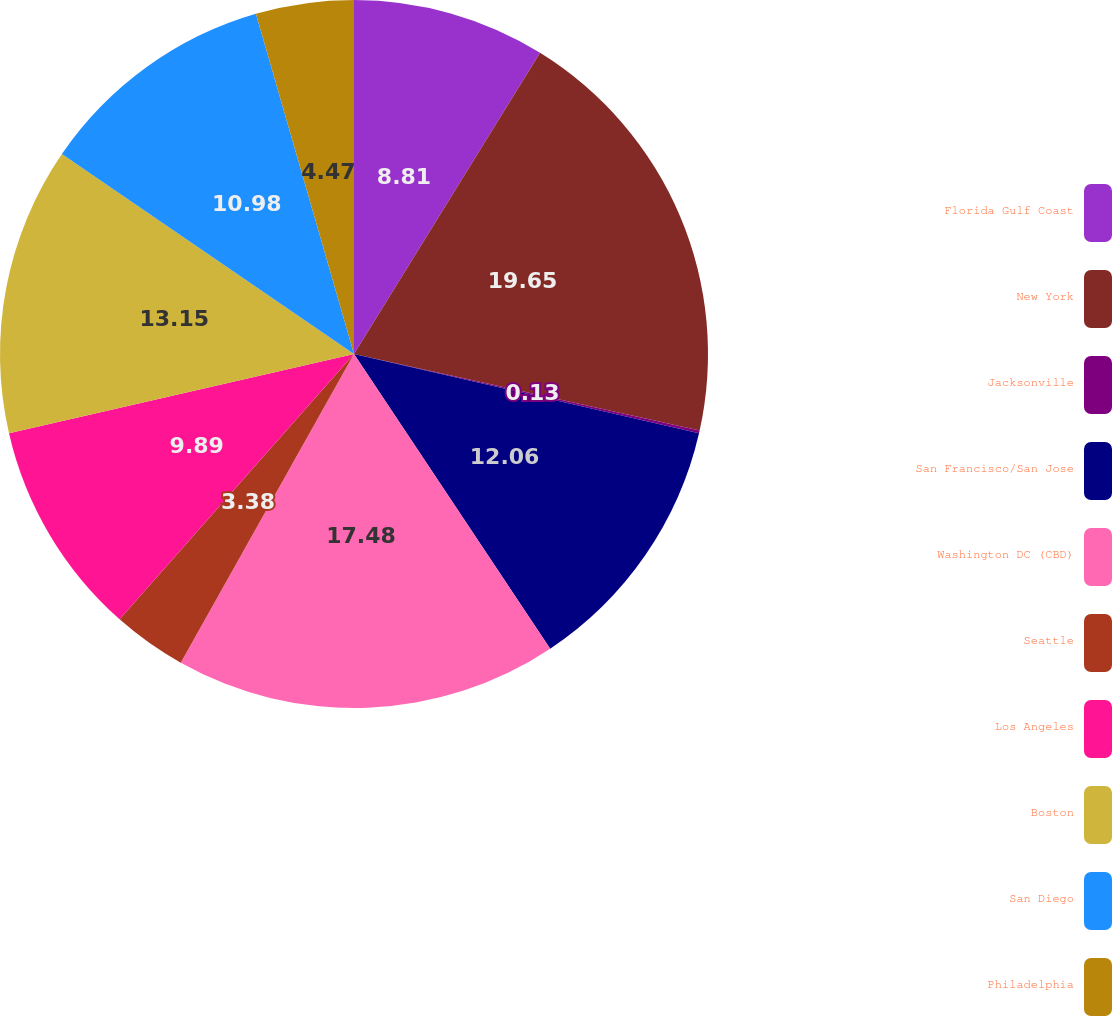Convert chart. <chart><loc_0><loc_0><loc_500><loc_500><pie_chart><fcel>Florida Gulf Coast<fcel>New York<fcel>Jacksonville<fcel>San Francisco/San Jose<fcel>Washington DC (CBD)<fcel>Seattle<fcel>Los Angeles<fcel>Boston<fcel>San Diego<fcel>Philadelphia<nl><fcel>8.81%<fcel>19.66%<fcel>0.13%<fcel>12.06%<fcel>17.49%<fcel>3.38%<fcel>9.89%<fcel>13.15%<fcel>10.98%<fcel>4.47%<nl></chart> 